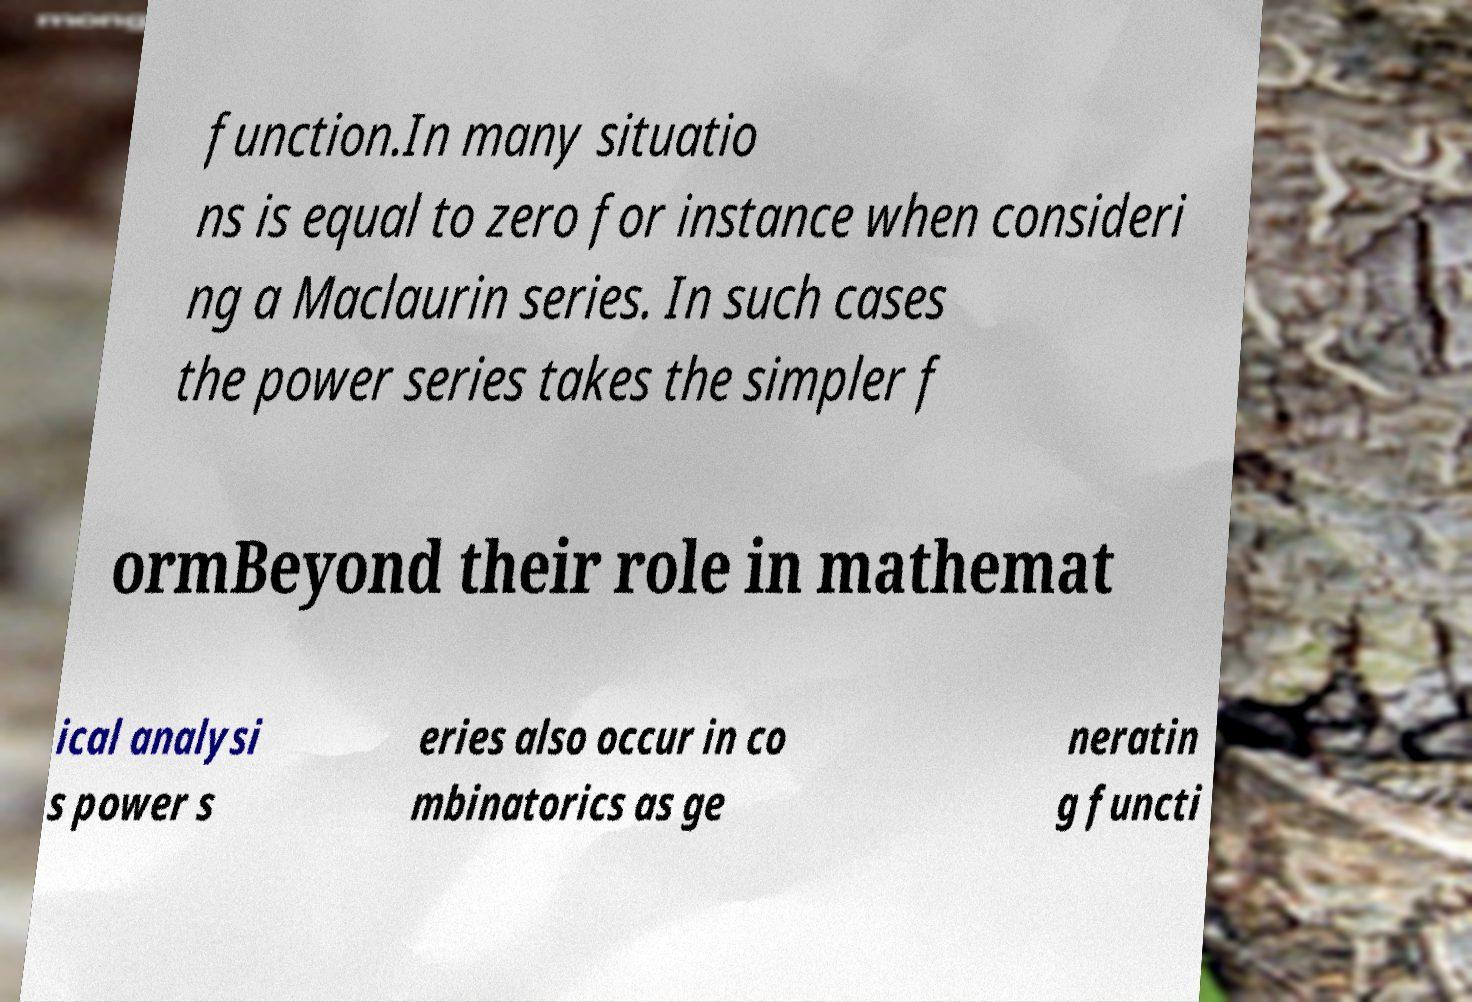Please read and relay the text visible in this image. What does it say? function.In many situatio ns is equal to zero for instance when consideri ng a Maclaurin series. In such cases the power series takes the simpler f ormBeyond their role in mathemat ical analysi s power s eries also occur in co mbinatorics as ge neratin g functi 